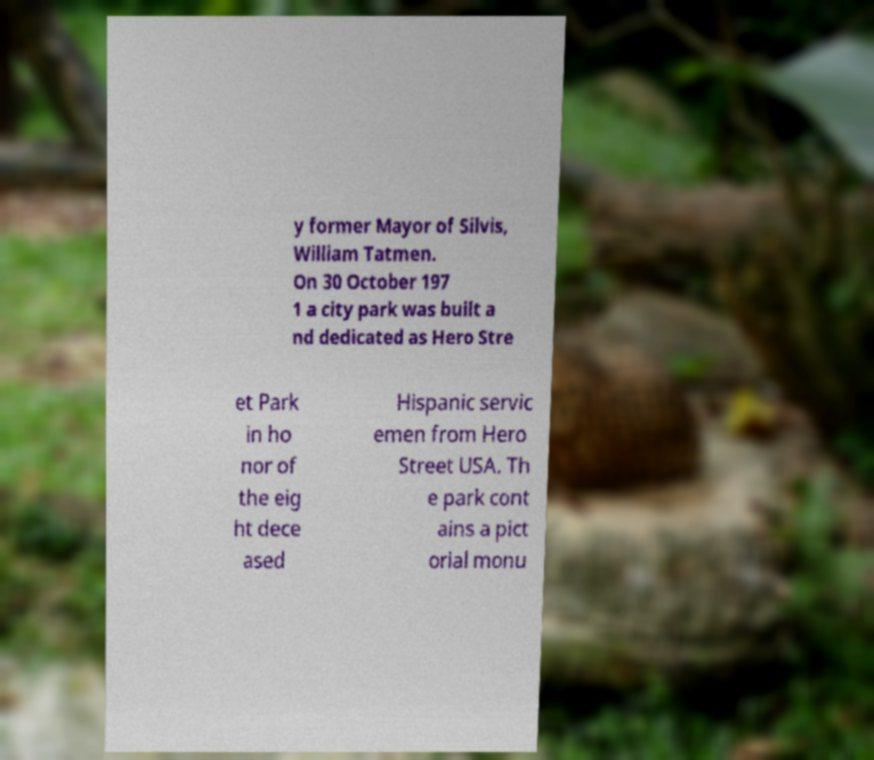There's text embedded in this image that I need extracted. Can you transcribe it verbatim? y former Mayor of Silvis, William Tatmen. On 30 October 197 1 a city park was built a nd dedicated as Hero Stre et Park in ho nor of the eig ht dece ased Hispanic servic emen from Hero Street USA. Th e park cont ains a pict orial monu 